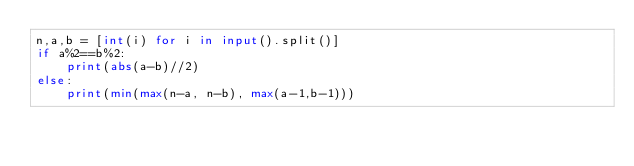<code> <loc_0><loc_0><loc_500><loc_500><_Python_>n,a,b = [int(i) for i in input().split()]
if a%2==b%2:
    print(abs(a-b)//2)
else:
    print(min(max(n-a, n-b), max(a-1,b-1)))</code> 